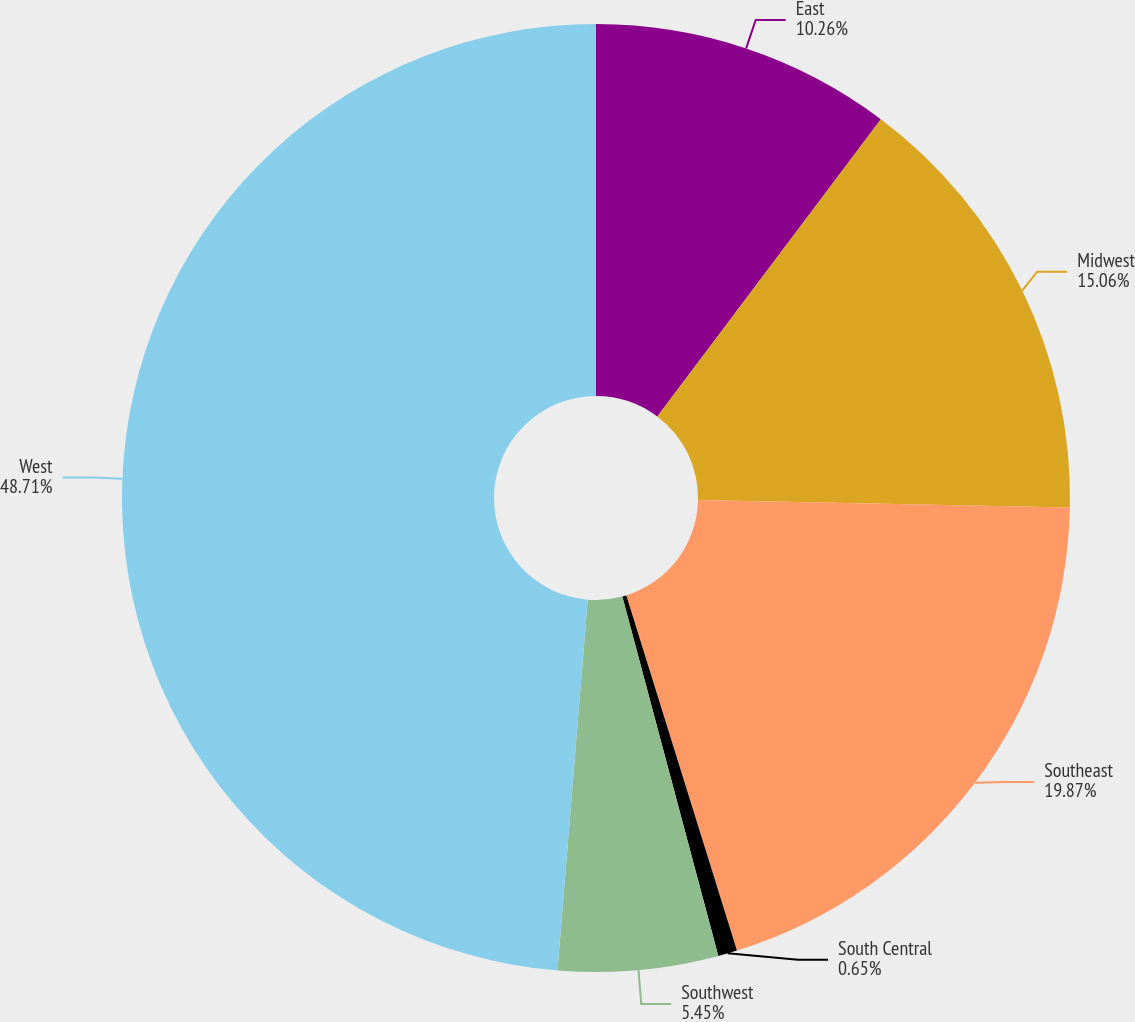Convert chart. <chart><loc_0><loc_0><loc_500><loc_500><pie_chart><fcel>East<fcel>Midwest<fcel>Southeast<fcel>South Central<fcel>Southwest<fcel>West<nl><fcel>10.26%<fcel>15.06%<fcel>19.87%<fcel>0.65%<fcel>5.45%<fcel>48.7%<nl></chart> 